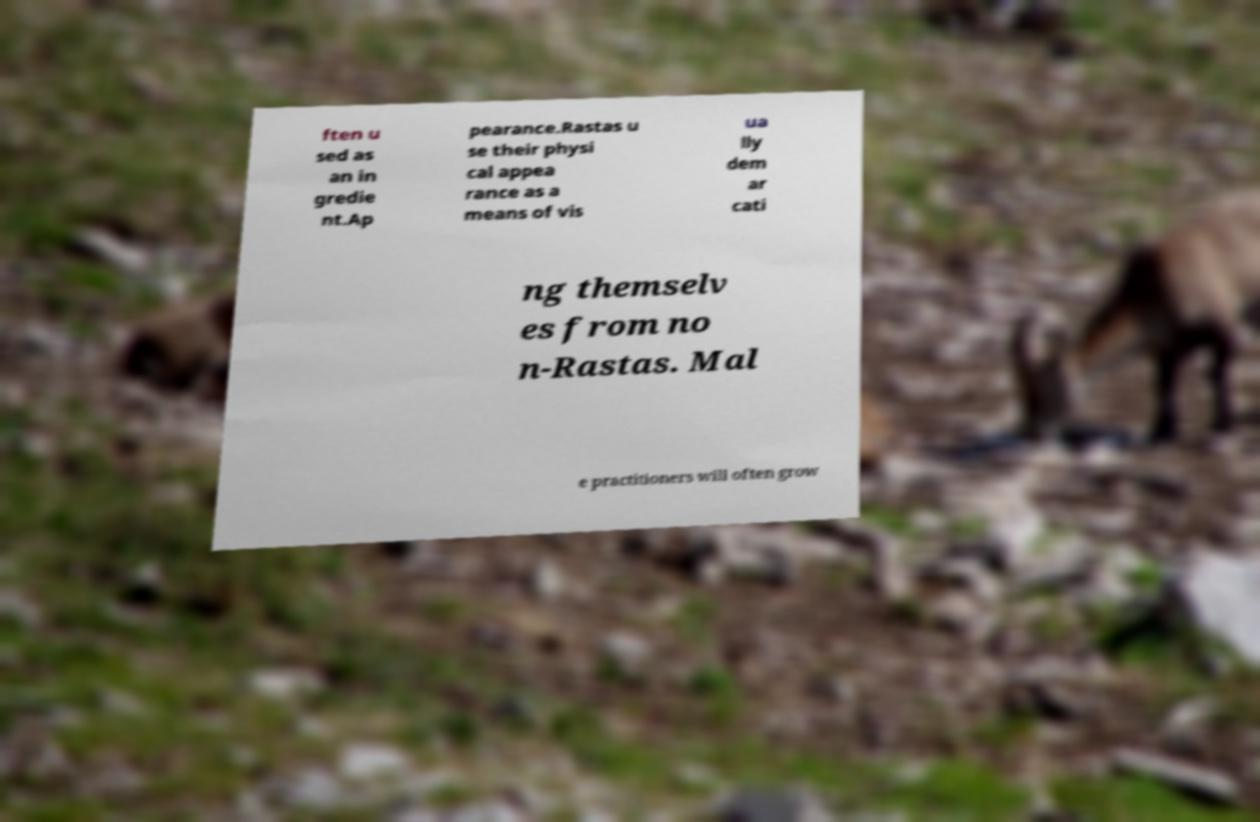Could you extract and type out the text from this image? ften u sed as an in gredie nt.Ap pearance.Rastas u se their physi cal appea rance as a means of vis ua lly dem ar cati ng themselv es from no n-Rastas. Mal e practitioners will often grow 